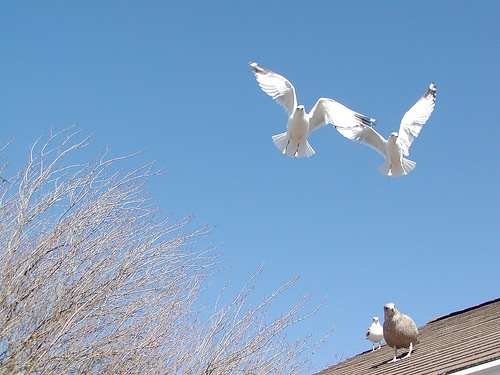<image>
Is there a bird above the roof? No. The bird is not positioned above the roof. The vertical arrangement shows a different relationship. 